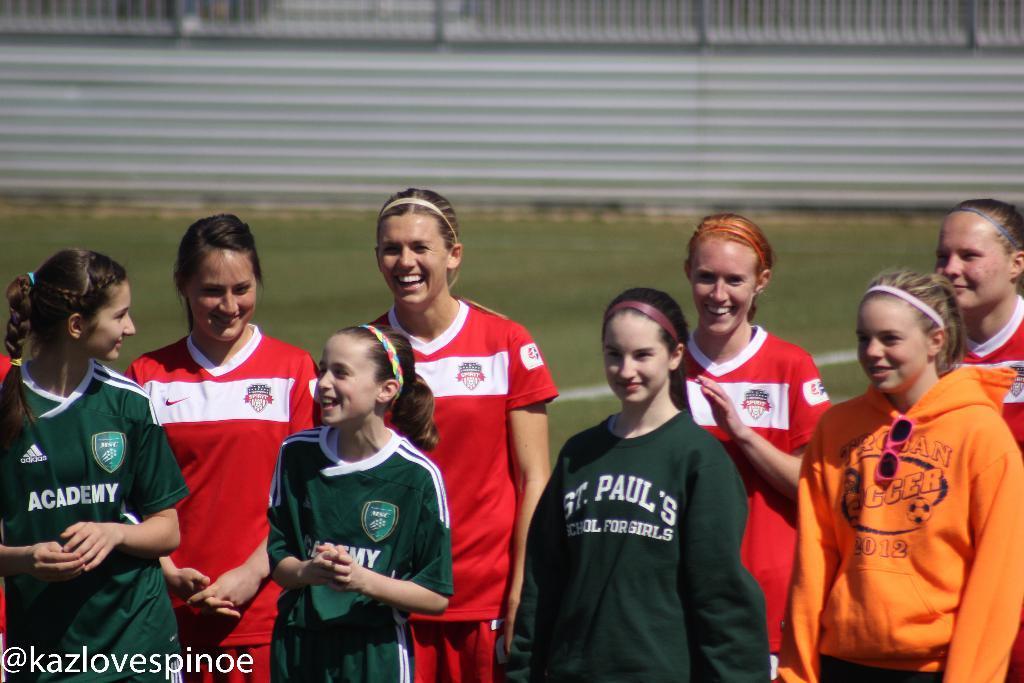Can you describe this image briefly? In the foreground of this image, there are women standing and having smile on their faces. In the background, there is grass and the boundary wall. 